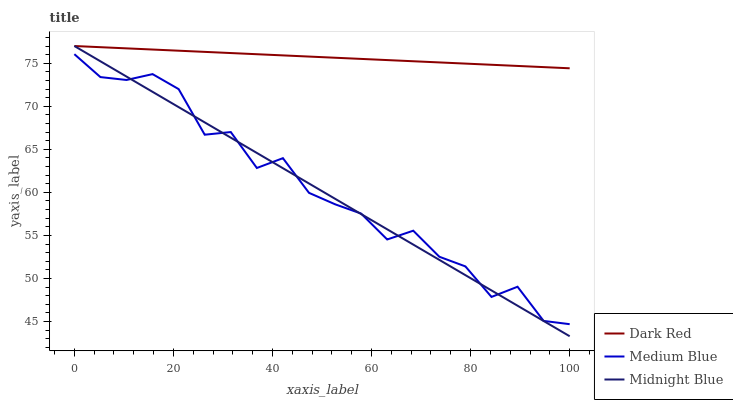Does Medium Blue have the minimum area under the curve?
Answer yes or no. No. Does Medium Blue have the maximum area under the curve?
Answer yes or no. No. Is Medium Blue the smoothest?
Answer yes or no. No. Is Midnight Blue the roughest?
Answer yes or no. No. Does Medium Blue have the lowest value?
Answer yes or no. No. Does Medium Blue have the highest value?
Answer yes or no. No. Is Medium Blue less than Dark Red?
Answer yes or no. Yes. Is Dark Red greater than Medium Blue?
Answer yes or no. Yes. Does Medium Blue intersect Dark Red?
Answer yes or no. No. 